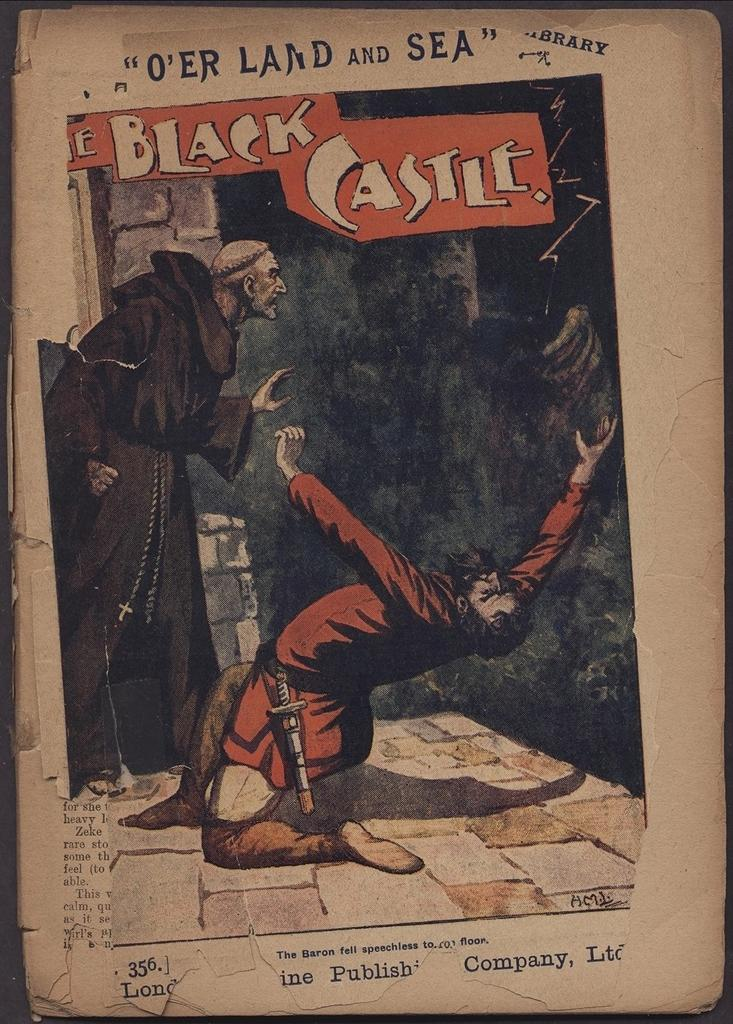<image>
Summarize the visual content of the image. A drawing that with the words The Black Castle written on it. 